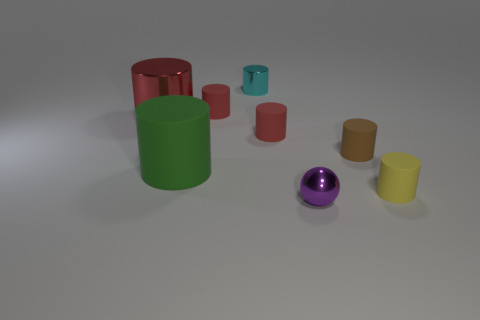The other large cylinder that is the same material as the yellow cylinder is what color?
Offer a terse response. Green. What number of gray objects are either tiny metallic objects or large cylinders?
Give a very brief answer. 0. Are there more large metallic objects than yellow metal objects?
Your answer should be very brief. Yes. What number of things are tiny rubber things that are on the right side of the purple metal sphere or matte things to the right of the green matte thing?
Make the answer very short. 4. There is a ball that is the same size as the brown rubber object; what is its color?
Your response must be concise. Purple. Do the yellow object and the tiny brown object have the same material?
Your response must be concise. Yes. There is a large object in front of the large red cylinder that is left of the yellow cylinder; what is it made of?
Ensure brevity in your answer.  Rubber. Is the number of cylinders on the left side of the shiny sphere greater than the number of purple shiny objects?
Provide a short and direct response. Yes. How many other objects are the same size as the green cylinder?
Give a very brief answer. 1. What color is the small shiny thing left of the tiny metallic object in front of the small cylinder in front of the brown matte thing?
Give a very brief answer. Cyan. 